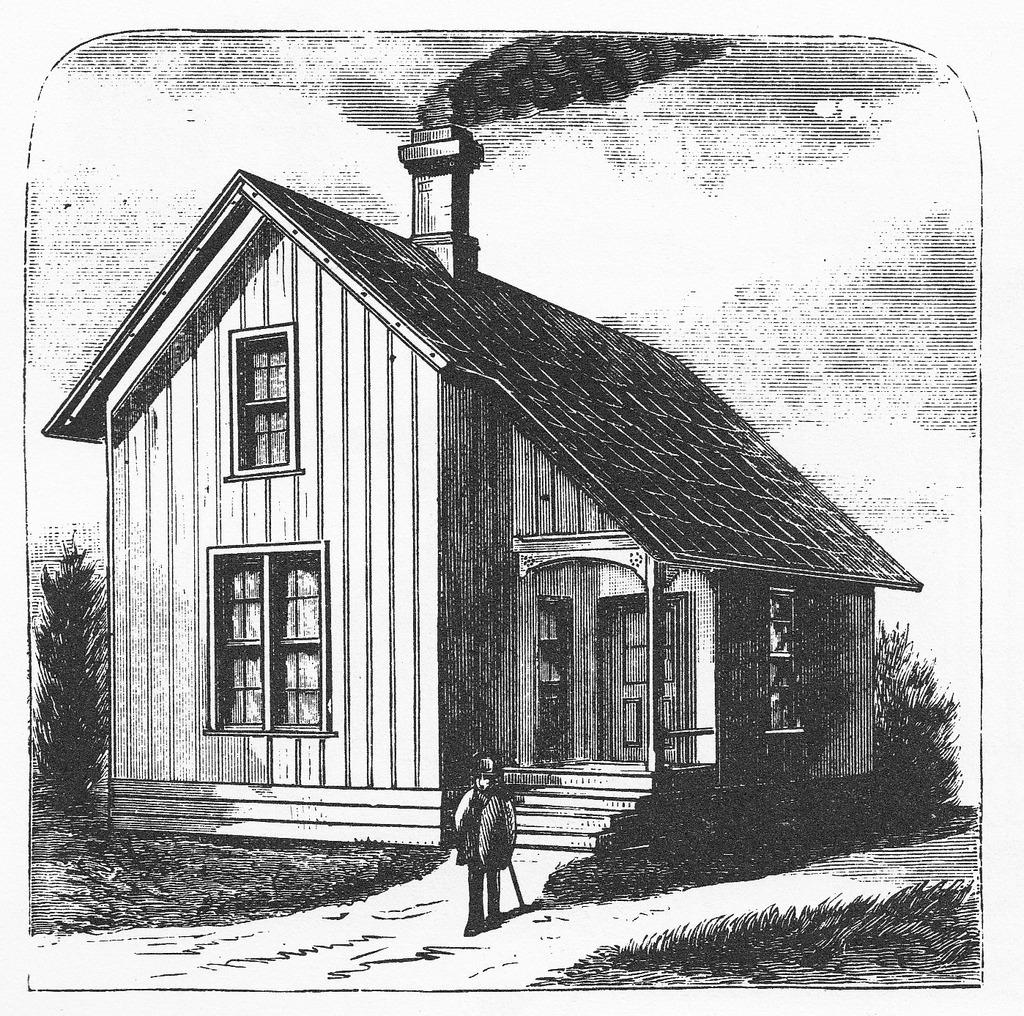What type of drawing can be seen in the image? There is a drawing of a person and a house in the image. What architectural features are depicted in the drawing of the house? There are drawings of doors and windows in the image. What natural elements are included in the drawing? There are drawings of plants in the image. What is the weather condition depicted in the drawing? There are drawings of clouds in the sky in the image. What is the source of the smoke in the drawing? The source of the smoke in the drawing is not specified. What type of appliance is being used to create the drawings in the image? There is no appliance visible in the image; it is a drawing, not a photograph or video. 